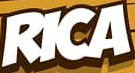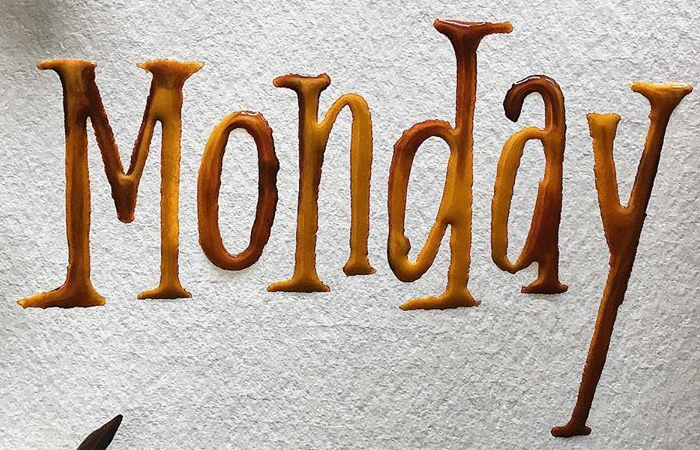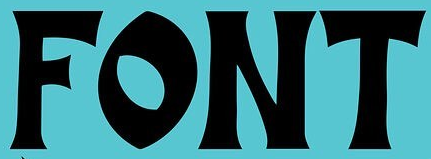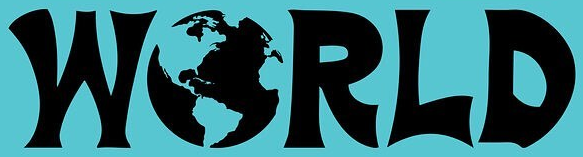What words are shown in these images in order, separated by a semicolon? RICA; Monday; FONT; WORLD 